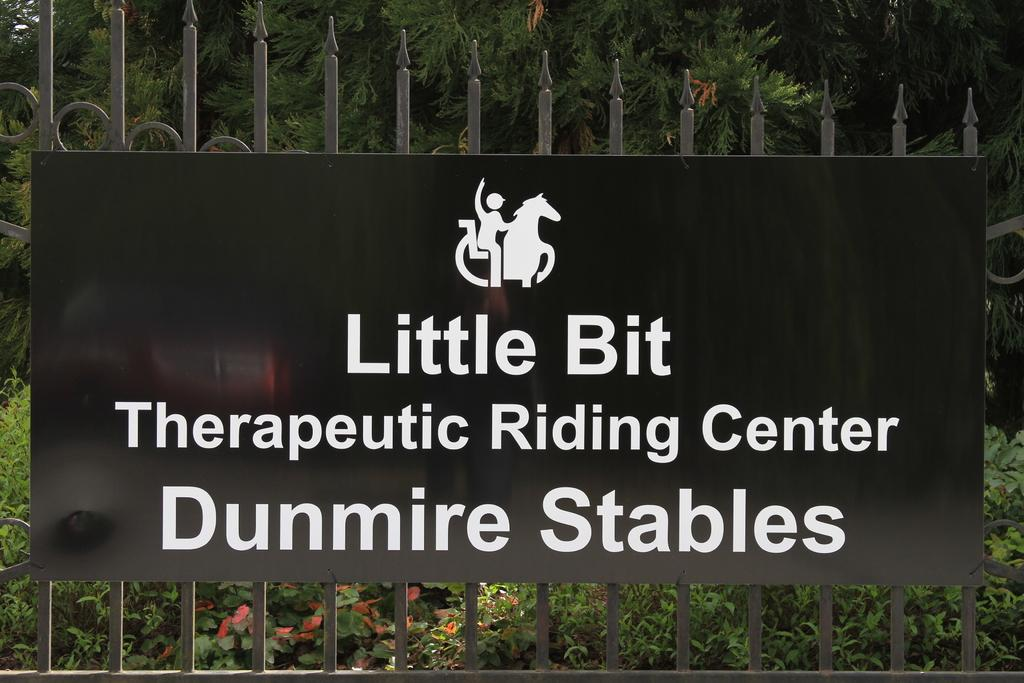What is attached to the fence in the image? There is a board on a fence in the image. What can be seen on the board? The board has a picture and text on it. What is visible on the other side of the fence? There is a group of plants and trees visible on the backside of the fence. What type of boot is being compared to the picture on the board in the image? There is no boot present in the image, nor is there any comparison being made. 